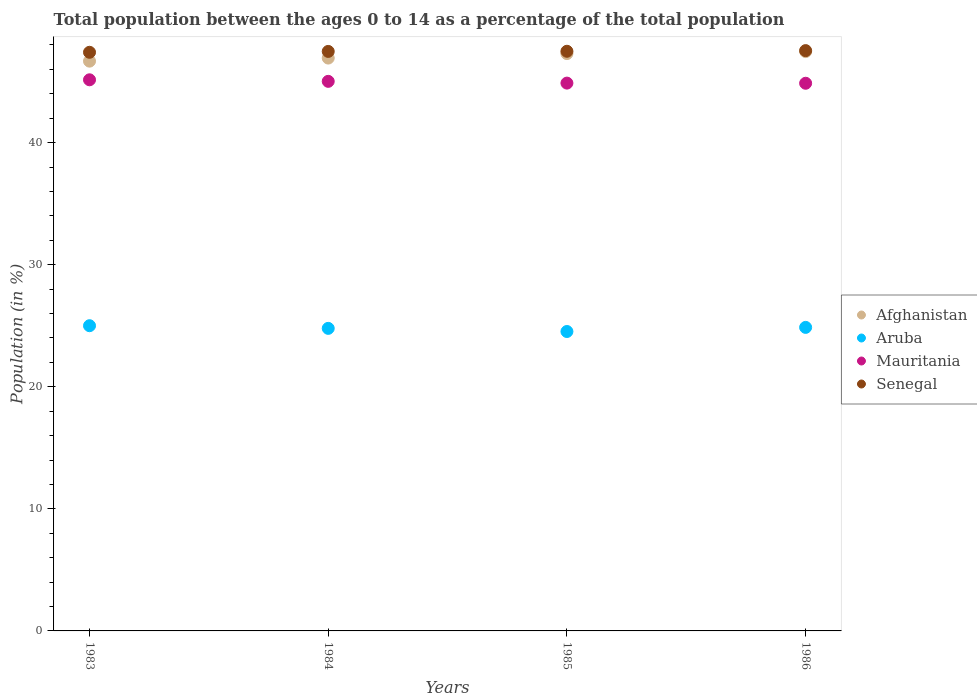How many different coloured dotlines are there?
Offer a terse response. 4. Is the number of dotlines equal to the number of legend labels?
Make the answer very short. Yes. What is the percentage of the population ages 0 to 14 in Mauritania in 1984?
Offer a terse response. 45.02. Across all years, what is the maximum percentage of the population ages 0 to 14 in Mauritania?
Your response must be concise. 45.15. Across all years, what is the minimum percentage of the population ages 0 to 14 in Afghanistan?
Ensure brevity in your answer.  46.68. What is the total percentage of the population ages 0 to 14 in Afghanistan in the graph?
Offer a very short reply. 188.36. What is the difference between the percentage of the population ages 0 to 14 in Afghanistan in 1983 and that in 1985?
Your response must be concise. -0.62. What is the difference between the percentage of the population ages 0 to 14 in Mauritania in 1983 and the percentage of the population ages 0 to 14 in Aruba in 1986?
Give a very brief answer. 20.28. What is the average percentage of the population ages 0 to 14 in Senegal per year?
Provide a succinct answer. 47.48. In the year 1986, what is the difference between the percentage of the population ages 0 to 14 in Mauritania and percentage of the population ages 0 to 14 in Aruba?
Offer a very short reply. 20. In how many years, is the percentage of the population ages 0 to 14 in Mauritania greater than 12?
Give a very brief answer. 4. What is the ratio of the percentage of the population ages 0 to 14 in Aruba in 1983 to that in 1985?
Offer a very short reply. 1.02. Is the percentage of the population ages 0 to 14 in Aruba in 1983 less than that in 1985?
Make the answer very short. No. What is the difference between the highest and the second highest percentage of the population ages 0 to 14 in Aruba?
Make the answer very short. 0.14. What is the difference between the highest and the lowest percentage of the population ages 0 to 14 in Aruba?
Provide a short and direct response. 0.47. In how many years, is the percentage of the population ages 0 to 14 in Aruba greater than the average percentage of the population ages 0 to 14 in Aruba taken over all years?
Make the answer very short. 2. Is it the case that in every year, the sum of the percentage of the population ages 0 to 14 in Mauritania and percentage of the population ages 0 to 14 in Aruba  is greater than the sum of percentage of the population ages 0 to 14 in Senegal and percentage of the population ages 0 to 14 in Afghanistan?
Your answer should be very brief. Yes. Does the percentage of the population ages 0 to 14 in Afghanistan monotonically increase over the years?
Your answer should be compact. Yes. Is the percentage of the population ages 0 to 14 in Aruba strictly less than the percentage of the population ages 0 to 14 in Afghanistan over the years?
Offer a terse response. Yes. How many years are there in the graph?
Offer a terse response. 4. Are the values on the major ticks of Y-axis written in scientific E-notation?
Give a very brief answer. No. Does the graph contain any zero values?
Offer a very short reply. No. How many legend labels are there?
Give a very brief answer. 4. What is the title of the graph?
Offer a very short reply. Total population between the ages 0 to 14 as a percentage of the total population. What is the label or title of the Y-axis?
Give a very brief answer. Population (in %). What is the Population (in %) in Afghanistan in 1983?
Your answer should be compact. 46.68. What is the Population (in %) in Aruba in 1983?
Give a very brief answer. 25. What is the Population (in %) of Mauritania in 1983?
Keep it short and to the point. 45.15. What is the Population (in %) in Senegal in 1983?
Your response must be concise. 47.4. What is the Population (in %) of Afghanistan in 1984?
Give a very brief answer. 46.93. What is the Population (in %) of Aruba in 1984?
Keep it short and to the point. 24.79. What is the Population (in %) in Mauritania in 1984?
Ensure brevity in your answer.  45.02. What is the Population (in %) in Senegal in 1984?
Your answer should be compact. 47.47. What is the Population (in %) in Afghanistan in 1985?
Offer a very short reply. 47.3. What is the Population (in %) in Aruba in 1985?
Ensure brevity in your answer.  24.53. What is the Population (in %) of Mauritania in 1985?
Offer a terse response. 44.88. What is the Population (in %) of Senegal in 1985?
Offer a very short reply. 47.49. What is the Population (in %) in Afghanistan in 1986?
Your answer should be very brief. 47.46. What is the Population (in %) in Aruba in 1986?
Ensure brevity in your answer.  24.87. What is the Population (in %) in Mauritania in 1986?
Give a very brief answer. 44.87. What is the Population (in %) in Senegal in 1986?
Offer a terse response. 47.54. Across all years, what is the maximum Population (in %) of Afghanistan?
Ensure brevity in your answer.  47.46. Across all years, what is the maximum Population (in %) in Aruba?
Make the answer very short. 25. Across all years, what is the maximum Population (in %) of Mauritania?
Keep it short and to the point. 45.15. Across all years, what is the maximum Population (in %) of Senegal?
Offer a terse response. 47.54. Across all years, what is the minimum Population (in %) of Afghanistan?
Keep it short and to the point. 46.68. Across all years, what is the minimum Population (in %) of Aruba?
Give a very brief answer. 24.53. Across all years, what is the minimum Population (in %) of Mauritania?
Your answer should be very brief. 44.87. Across all years, what is the minimum Population (in %) of Senegal?
Offer a terse response. 47.4. What is the total Population (in %) of Afghanistan in the graph?
Your answer should be very brief. 188.36. What is the total Population (in %) of Aruba in the graph?
Ensure brevity in your answer.  99.18. What is the total Population (in %) of Mauritania in the graph?
Keep it short and to the point. 179.91. What is the total Population (in %) of Senegal in the graph?
Give a very brief answer. 189.9. What is the difference between the Population (in %) in Afghanistan in 1983 and that in 1984?
Your answer should be very brief. -0.25. What is the difference between the Population (in %) in Aruba in 1983 and that in 1984?
Offer a very short reply. 0.22. What is the difference between the Population (in %) in Mauritania in 1983 and that in 1984?
Make the answer very short. 0.13. What is the difference between the Population (in %) in Senegal in 1983 and that in 1984?
Your answer should be very brief. -0.07. What is the difference between the Population (in %) in Afghanistan in 1983 and that in 1985?
Offer a terse response. -0.62. What is the difference between the Population (in %) in Aruba in 1983 and that in 1985?
Offer a terse response. 0.47. What is the difference between the Population (in %) of Mauritania in 1983 and that in 1985?
Offer a terse response. 0.27. What is the difference between the Population (in %) of Senegal in 1983 and that in 1985?
Your answer should be compact. -0.08. What is the difference between the Population (in %) in Afghanistan in 1983 and that in 1986?
Offer a terse response. -0.78. What is the difference between the Population (in %) of Aruba in 1983 and that in 1986?
Your answer should be very brief. 0.14. What is the difference between the Population (in %) in Mauritania in 1983 and that in 1986?
Make the answer very short. 0.28. What is the difference between the Population (in %) in Senegal in 1983 and that in 1986?
Provide a succinct answer. -0.14. What is the difference between the Population (in %) in Afghanistan in 1984 and that in 1985?
Offer a very short reply. -0.37. What is the difference between the Population (in %) in Aruba in 1984 and that in 1985?
Ensure brevity in your answer.  0.26. What is the difference between the Population (in %) of Mauritania in 1984 and that in 1985?
Your response must be concise. 0.14. What is the difference between the Population (in %) in Senegal in 1984 and that in 1985?
Provide a succinct answer. -0.01. What is the difference between the Population (in %) of Afghanistan in 1984 and that in 1986?
Offer a terse response. -0.53. What is the difference between the Population (in %) in Aruba in 1984 and that in 1986?
Provide a short and direct response. -0.08. What is the difference between the Population (in %) of Mauritania in 1984 and that in 1986?
Provide a short and direct response. 0.16. What is the difference between the Population (in %) in Senegal in 1984 and that in 1986?
Offer a terse response. -0.07. What is the difference between the Population (in %) of Afghanistan in 1985 and that in 1986?
Provide a succinct answer. -0.16. What is the difference between the Population (in %) in Aruba in 1985 and that in 1986?
Ensure brevity in your answer.  -0.34. What is the difference between the Population (in %) of Mauritania in 1985 and that in 1986?
Provide a short and direct response. 0.01. What is the difference between the Population (in %) of Senegal in 1985 and that in 1986?
Your answer should be compact. -0.05. What is the difference between the Population (in %) of Afghanistan in 1983 and the Population (in %) of Aruba in 1984?
Your answer should be very brief. 21.89. What is the difference between the Population (in %) in Afghanistan in 1983 and the Population (in %) in Mauritania in 1984?
Give a very brief answer. 1.66. What is the difference between the Population (in %) in Afghanistan in 1983 and the Population (in %) in Senegal in 1984?
Your answer should be very brief. -0.8. What is the difference between the Population (in %) of Aruba in 1983 and the Population (in %) of Mauritania in 1984?
Ensure brevity in your answer.  -20.02. What is the difference between the Population (in %) in Aruba in 1983 and the Population (in %) in Senegal in 1984?
Offer a very short reply. -22.47. What is the difference between the Population (in %) of Mauritania in 1983 and the Population (in %) of Senegal in 1984?
Make the answer very short. -2.32. What is the difference between the Population (in %) in Afghanistan in 1983 and the Population (in %) in Aruba in 1985?
Provide a short and direct response. 22.15. What is the difference between the Population (in %) of Afghanistan in 1983 and the Population (in %) of Mauritania in 1985?
Your answer should be compact. 1.8. What is the difference between the Population (in %) in Afghanistan in 1983 and the Population (in %) in Senegal in 1985?
Your response must be concise. -0.81. What is the difference between the Population (in %) in Aruba in 1983 and the Population (in %) in Mauritania in 1985?
Offer a very short reply. -19.87. What is the difference between the Population (in %) of Aruba in 1983 and the Population (in %) of Senegal in 1985?
Provide a succinct answer. -22.48. What is the difference between the Population (in %) of Mauritania in 1983 and the Population (in %) of Senegal in 1985?
Provide a succinct answer. -2.34. What is the difference between the Population (in %) in Afghanistan in 1983 and the Population (in %) in Aruba in 1986?
Provide a short and direct response. 21.81. What is the difference between the Population (in %) in Afghanistan in 1983 and the Population (in %) in Mauritania in 1986?
Provide a short and direct response. 1.81. What is the difference between the Population (in %) of Afghanistan in 1983 and the Population (in %) of Senegal in 1986?
Keep it short and to the point. -0.86. What is the difference between the Population (in %) of Aruba in 1983 and the Population (in %) of Mauritania in 1986?
Offer a terse response. -19.86. What is the difference between the Population (in %) of Aruba in 1983 and the Population (in %) of Senegal in 1986?
Keep it short and to the point. -22.54. What is the difference between the Population (in %) of Mauritania in 1983 and the Population (in %) of Senegal in 1986?
Ensure brevity in your answer.  -2.39. What is the difference between the Population (in %) of Afghanistan in 1984 and the Population (in %) of Aruba in 1985?
Make the answer very short. 22.4. What is the difference between the Population (in %) in Afghanistan in 1984 and the Population (in %) in Mauritania in 1985?
Your response must be concise. 2.05. What is the difference between the Population (in %) of Afghanistan in 1984 and the Population (in %) of Senegal in 1985?
Provide a short and direct response. -0.56. What is the difference between the Population (in %) of Aruba in 1984 and the Population (in %) of Mauritania in 1985?
Your answer should be very brief. -20.09. What is the difference between the Population (in %) in Aruba in 1984 and the Population (in %) in Senegal in 1985?
Give a very brief answer. -22.7. What is the difference between the Population (in %) in Mauritania in 1984 and the Population (in %) in Senegal in 1985?
Ensure brevity in your answer.  -2.46. What is the difference between the Population (in %) in Afghanistan in 1984 and the Population (in %) in Aruba in 1986?
Keep it short and to the point. 22.06. What is the difference between the Population (in %) in Afghanistan in 1984 and the Population (in %) in Mauritania in 1986?
Your response must be concise. 2.06. What is the difference between the Population (in %) of Afghanistan in 1984 and the Population (in %) of Senegal in 1986?
Make the answer very short. -0.61. What is the difference between the Population (in %) of Aruba in 1984 and the Population (in %) of Mauritania in 1986?
Give a very brief answer. -20.08. What is the difference between the Population (in %) in Aruba in 1984 and the Population (in %) in Senegal in 1986?
Provide a short and direct response. -22.75. What is the difference between the Population (in %) in Mauritania in 1984 and the Population (in %) in Senegal in 1986?
Your answer should be compact. -2.52. What is the difference between the Population (in %) of Afghanistan in 1985 and the Population (in %) of Aruba in 1986?
Your answer should be very brief. 22.43. What is the difference between the Population (in %) of Afghanistan in 1985 and the Population (in %) of Mauritania in 1986?
Keep it short and to the point. 2.43. What is the difference between the Population (in %) in Afghanistan in 1985 and the Population (in %) in Senegal in 1986?
Your answer should be very brief. -0.24. What is the difference between the Population (in %) in Aruba in 1985 and the Population (in %) in Mauritania in 1986?
Your response must be concise. -20.34. What is the difference between the Population (in %) of Aruba in 1985 and the Population (in %) of Senegal in 1986?
Give a very brief answer. -23.01. What is the difference between the Population (in %) in Mauritania in 1985 and the Population (in %) in Senegal in 1986?
Your answer should be compact. -2.66. What is the average Population (in %) of Afghanistan per year?
Make the answer very short. 47.09. What is the average Population (in %) in Aruba per year?
Provide a succinct answer. 24.8. What is the average Population (in %) in Mauritania per year?
Provide a short and direct response. 44.98. What is the average Population (in %) in Senegal per year?
Provide a short and direct response. 47.48. In the year 1983, what is the difference between the Population (in %) in Afghanistan and Population (in %) in Aruba?
Your answer should be compact. 21.67. In the year 1983, what is the difference between the Population (in %) in Afghanistan and Population (in %) in Mauritania?
Your answer should be very brief. 1.53. In the year 1983, what is the difference between the Population (in %) in Afghanistan and Population (in %) in Senegal?
Your response must be concise. -0.73. In the year 1983, what is the difference between the Population (in %) in Aruba and Population (in %) in Mauritania?
Ensure brevity in your answer.  -20.15. In the year 1983, what is the difference between the Population (in %) of Aruba and Population (in %) of Senegal?
Keep it short and to the point. -22.4. In the year 1983, what is the difference between the Population (in %) of Mauritania and Population (in %) of Senegal?
Your response must be concise. -2.25. In the year 1984, what is the difference between the Population (in %) in Afghanistan and Population (in %) in Aruba?
Ensure brevity in your answer.  22.14. In the year 1984, what is the difference between the Population (in %) of Afghanistan and Population (in %) of Mauritania?
Your answer should be compact. 1.91. In the year 1984, what is the difference between the Population (in %) in Afghanistan and Population (in %) in Senegal?
Your answer should be very brief. -0.54. In the year 1984, what is the difference between the Population (in %) in Aruba and Population (in %) in Mauritania?
Make the answer very short. -20.24. In the year 1984, what is the difference between the Population (in %) in Aruba and Population (in %) in Senegal?
Ensure brevity in your answer.  -22.69. In the year 1984, what is the difference between the Population (in %) in Mauritania and Population (in %) in Senegal?
Give a very brief answer. -2.45. In the year 1985, what is the difference between the Population (in %) in Afghanistan and Population (in %) in Aruba?
Offer a very short reply. 22.77. In the year 1985, what is the difference between the Population (in %) in Afghanistan and Population (in %) in Mauritania?
Offer a terse response. 2.42. In the year 1985, what is the difference between the Population (in %) of Afghanistan and Population (in %) of Senegal?
Provide a succinct answer. -0.19. In the year 1985, what is the difference between the Population (in %) of Aruba and Population (in %) of Mauritania?
Ensure brevity in your answer.  -20.35. In the year 1985, what is the difference between the Population (in %) of Aruba and Population (in %) of Senegal?
Keep it short and to the point. -22.96. In the year 1985, what is the difference between the Population (in %) of Mauritania and Population (in %) of Senegal?
Provide a short and direct response. -2.61. In the year 1986, what is the difference between the Population (in %) in Afghanistan and Population (in %) in Aruba?
Make the answer very short. 22.59. In the year 1986, what is the difference between the Population (in %) of Afghanistan and Population (in %) of Mauritania?
Provide a short and direct response. 2.59. In the year 1986, what is the difference between the Population (in %) in Afghanistan and Population (in %) in Senegal?
Offer a terse response. -0.08. In the year 1986, what is the difference between the Population (in %) in Aruba and Population (in %) in Mauritania?
Provide a short and direct response. -20. In the year 1986, what is the difference between the Population (in %) of Aruba and Population (in %) of Senegal?
Keep it short and to the point. -22.67. In the year 1986, what is the difference between the Population (in %) in Mauritania and Population (in %) in Senegal?
Provide a succinct answer. -2.67. What is the ratio of the Population (in %) in Afghanistan in 1983 to that in 1984?
Give a very brief answer. 0.99. What is the ratio of the Population (in %) of Aruba in 1983 to that in 1984?
Offer a very short reply. 1.01. What is the ratio of the Population (in %) of Mauritania in 1983 to that in 1984?
Your answer should be compact. 1. What is the ratio of the Population (in %) of Afghanistan in 1983 to that in 1985?
Offer a terse response. 0.99. What is the ratio of the Population (in %) of Aruba in 1983 to that in 1985?
Keep it short and to the point. 1.02. What is the ratio of the Population (in %) of Afghanistan in 1983 to that in 1986?
Provide a succinct answer. 0.98. What is the ratio of the Population (in %) in Mauritania in 1983 to that in 1986?
Provide a succinct answer. 1.01. What is the ratio of the Population (in %) of Afghanistan in 1984 to that in 1985?
Keep it short and to the point. 0.99. What is the ratio of the Population (in %) of Aruba in 1984 to that in 1985?
Give a very brief answer. 1.01. What is the ratio of the Population (in %) of Afghanistan in 1984 to that in 1986?
Make the answer very short. 0.99. What is the ratio of the Population (in %) in Aruba in 1984 to that in 1986?
Your response must be concise. 1. What is the ratio of the Population (in %) of Aruba in 1985 to that in 1986?
Offer a very short reply. 0.99. What is the ratio of the Population (in %) in Mauritania in 1985 to that in 1986?
Your answer should be very brief. 1. What is the difference between the highest and the second highest Population (in %) in Afghanistan?
Give a very brief answer. 0.16. What is the difference between the highest and the second highest Population (in %) of Aruba?
Your answer should be compact. 0.14. What is the difference between the highest and the second highest Population (in %) in Mauritania?
Your response must be concise. 0.13. What is the difference between the highest and the second highest Population (in %) of Senegal?
Offer a very short reply. 0.05. What is the difference between the highest and the lowest Population (in %) in Afghanistan?
Offer a terse response. 0.78. What is the difference between the highest and the lowest Population (in %) of Aruba?
Keep it short and to the point. 0.47. What is the difference between the highest and the lowest Population (in %) in Mauritania?
Make the answer very short. 0.28. What is the difference between the highest and the lowest Population (in %) of Senegal?
Your answer should be very brief. 0.14. 